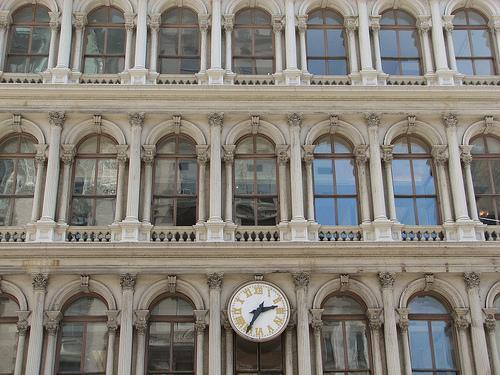How many rows of windows do you see?
Give a very brief answer. 3. 